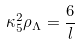<formula> <loc_0><loc_0><loc_500><loc_500>\kappa _ { 5 } ^ { 2 } \rho _ { \Lambda } = \frac { 6 } { l }</formula> 